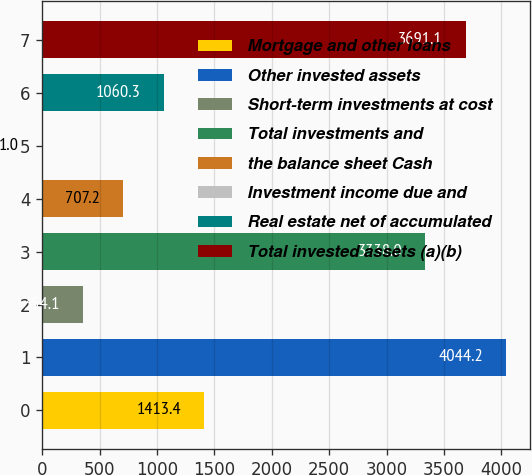Convert chart. <chart><loc_0><loc_0><loc_500><loc_500><bar_chart><fcel>Mortgage and other loans<fcel>Other invested assets<fcel>Short-term investments at cost<fcel>Total investments and<fcel>the balance sheet Cash<fcel>Investment income due and<fcel>Real estate net of accumulated<fcel>Total invested assets (a)(b)<nl><fcel>1413.4<fcel>4044.2<fcel>354.1<fcel>3338<fcel>707.2<fcel>1<fcel>1060.3<fcel>3691.1<nl></chart> 